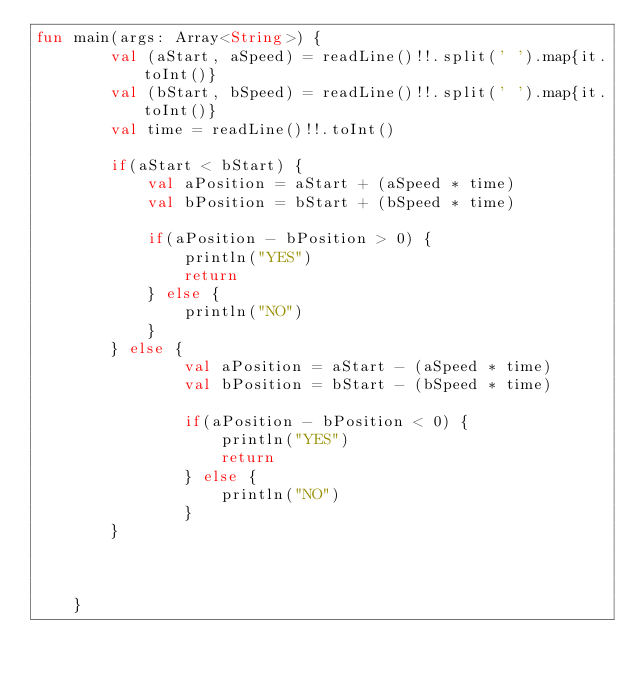Convert code to text. <code><loc_0><loc_0><loc_500><loc_500><_Kotlin_>fun main(args: Array<String>) {
        val (aStart, aSpeed) = readLine()!!.split(' ').map{it.toInt()}
        val (bStart, bSpeed) = readLine()!!.split(' ').map{it.toInt()}
        val time = readLine()!!.toInt()

        if(aStart < bStart) {
            val aPosition = aStart + (aSpeed * time)
            val bPosition = bStart + (bSpeed * time)

            if(aPosition - bPosition > 0) {
                println("YES")
                return
            } else {
                println("NO")
            }
        } else {
                val aPosition = aStart - (aSpeed * time)
                val bPosition = bStart - (bSpeed * time)

                if(aPosition - bPosition < 0) {
                    println("YES")
                    return
                } else {
                    println("NO")
                }
        }



    }</code> 